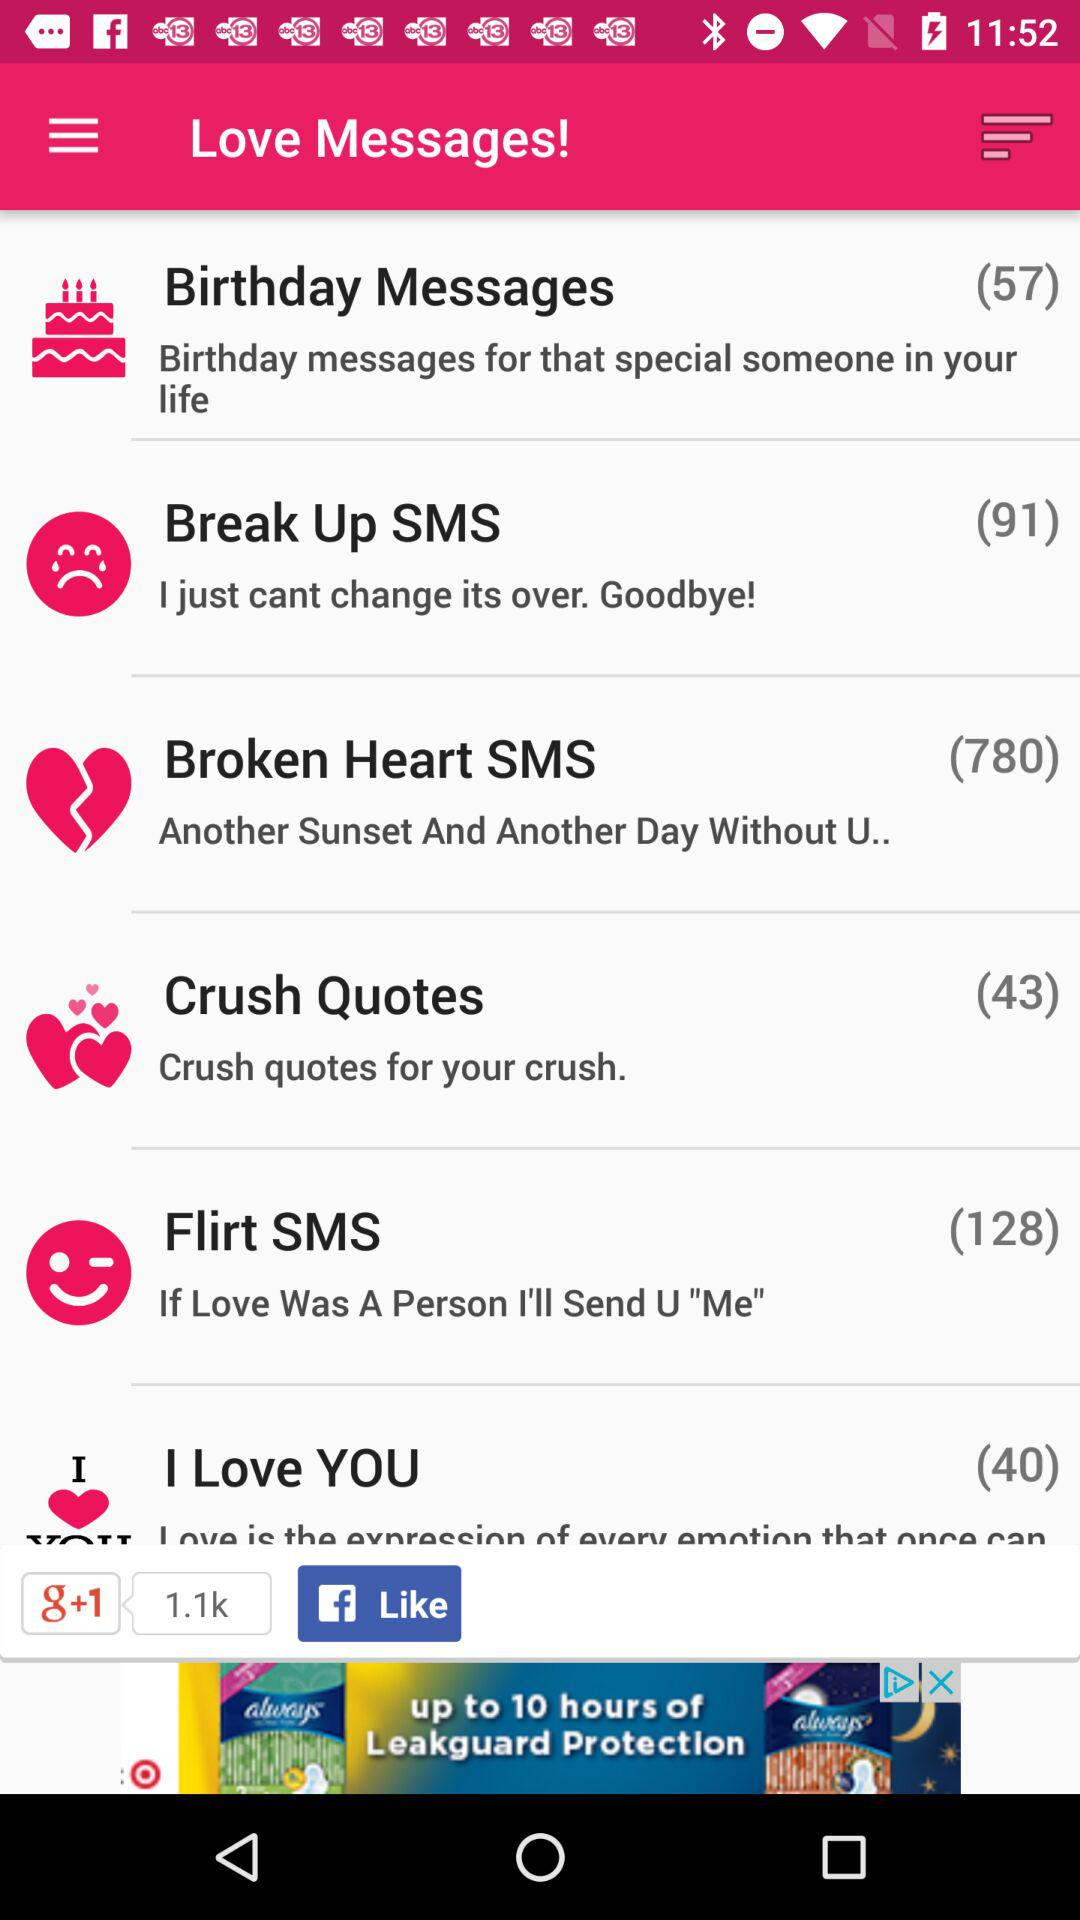Who is sending these love messages?
When the provided information is insufficient, respond with <no answer>. <no answer> 